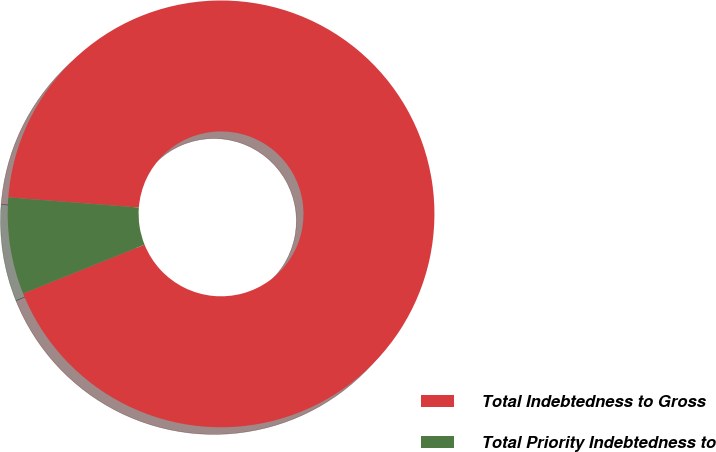Convert chart. <chart><loc_0><loc_0><loc_500><loc_500><pie_chart><fcel>Total Indebtedness to Gross<fcel>Total Priority Indebtedness to<nl><fcel>92.68%<fcel>7.32%<nl></chart> 